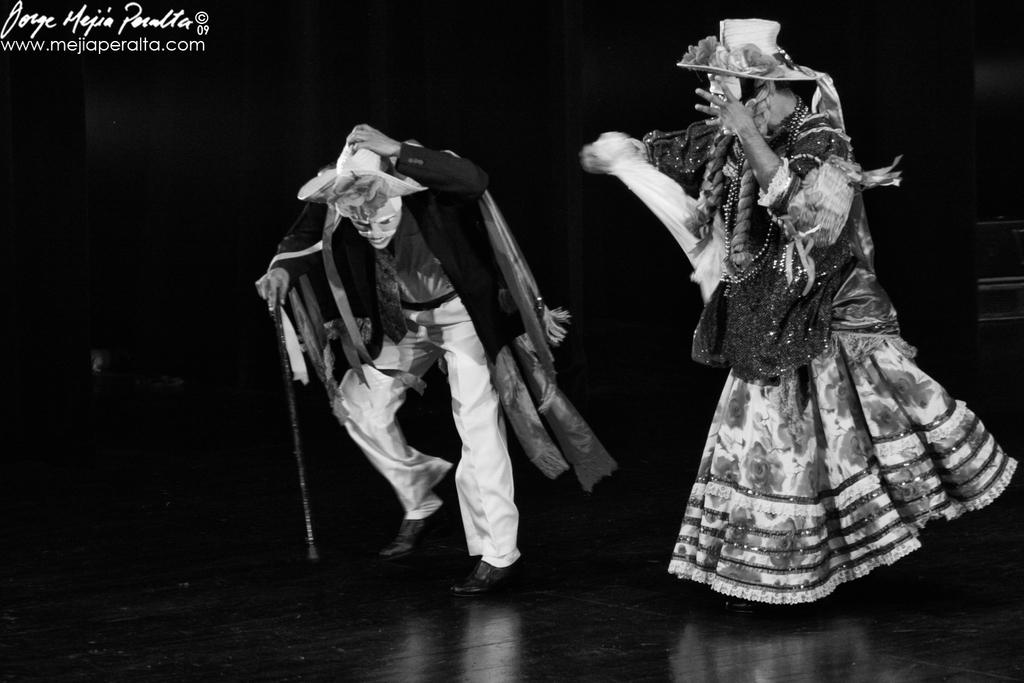What is the color scheme of the image? The image is black and white. How many persons are present in the image? There are two persons in the image. What are the persons wearing in the image? The persons are wearing dance costumes, masks, and hats. Where are the persons in the image? The persons are dancing on a stage. Can you tell me how many pumpkins are visible on the stage in the image? There are no pumpkins visible on the stage in the image. What type of quiet animal can be seen hiding behind the persons on the stage? There are no animals present in the image, let alone a quiet one hiding behind the persons on the stage. 